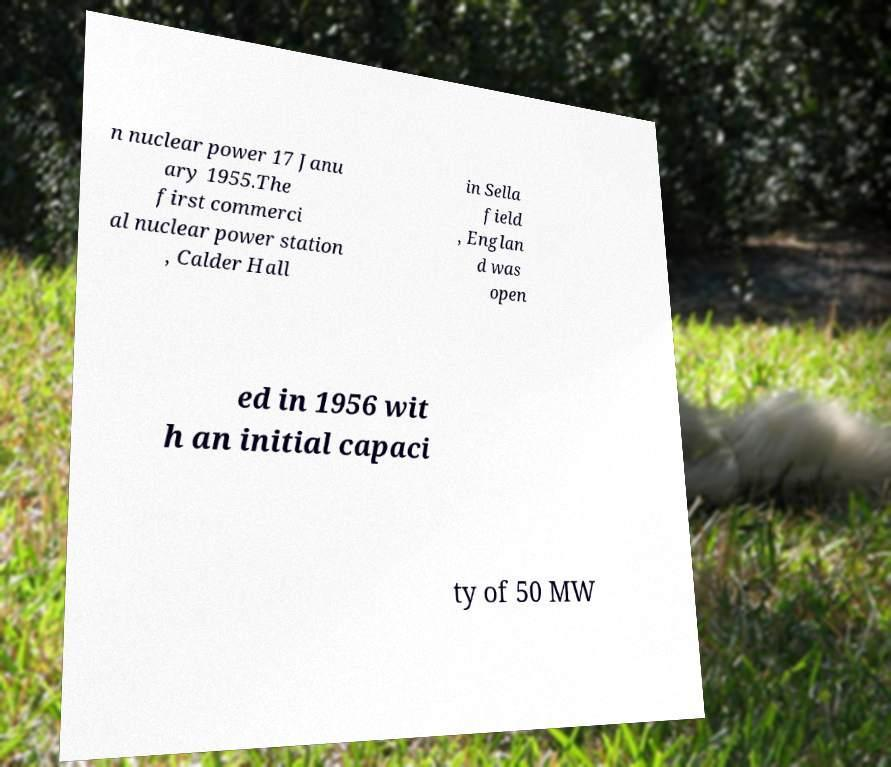What messages or text are displayed in this image? I need them in a readable, typed format. n nuclear power 17 Janu ary 1955.The first commerci al nuclear power station , Calder Hall in Sella field , Englan d was open ed in 1956 wit h an initial capaci ty of 50 MW 